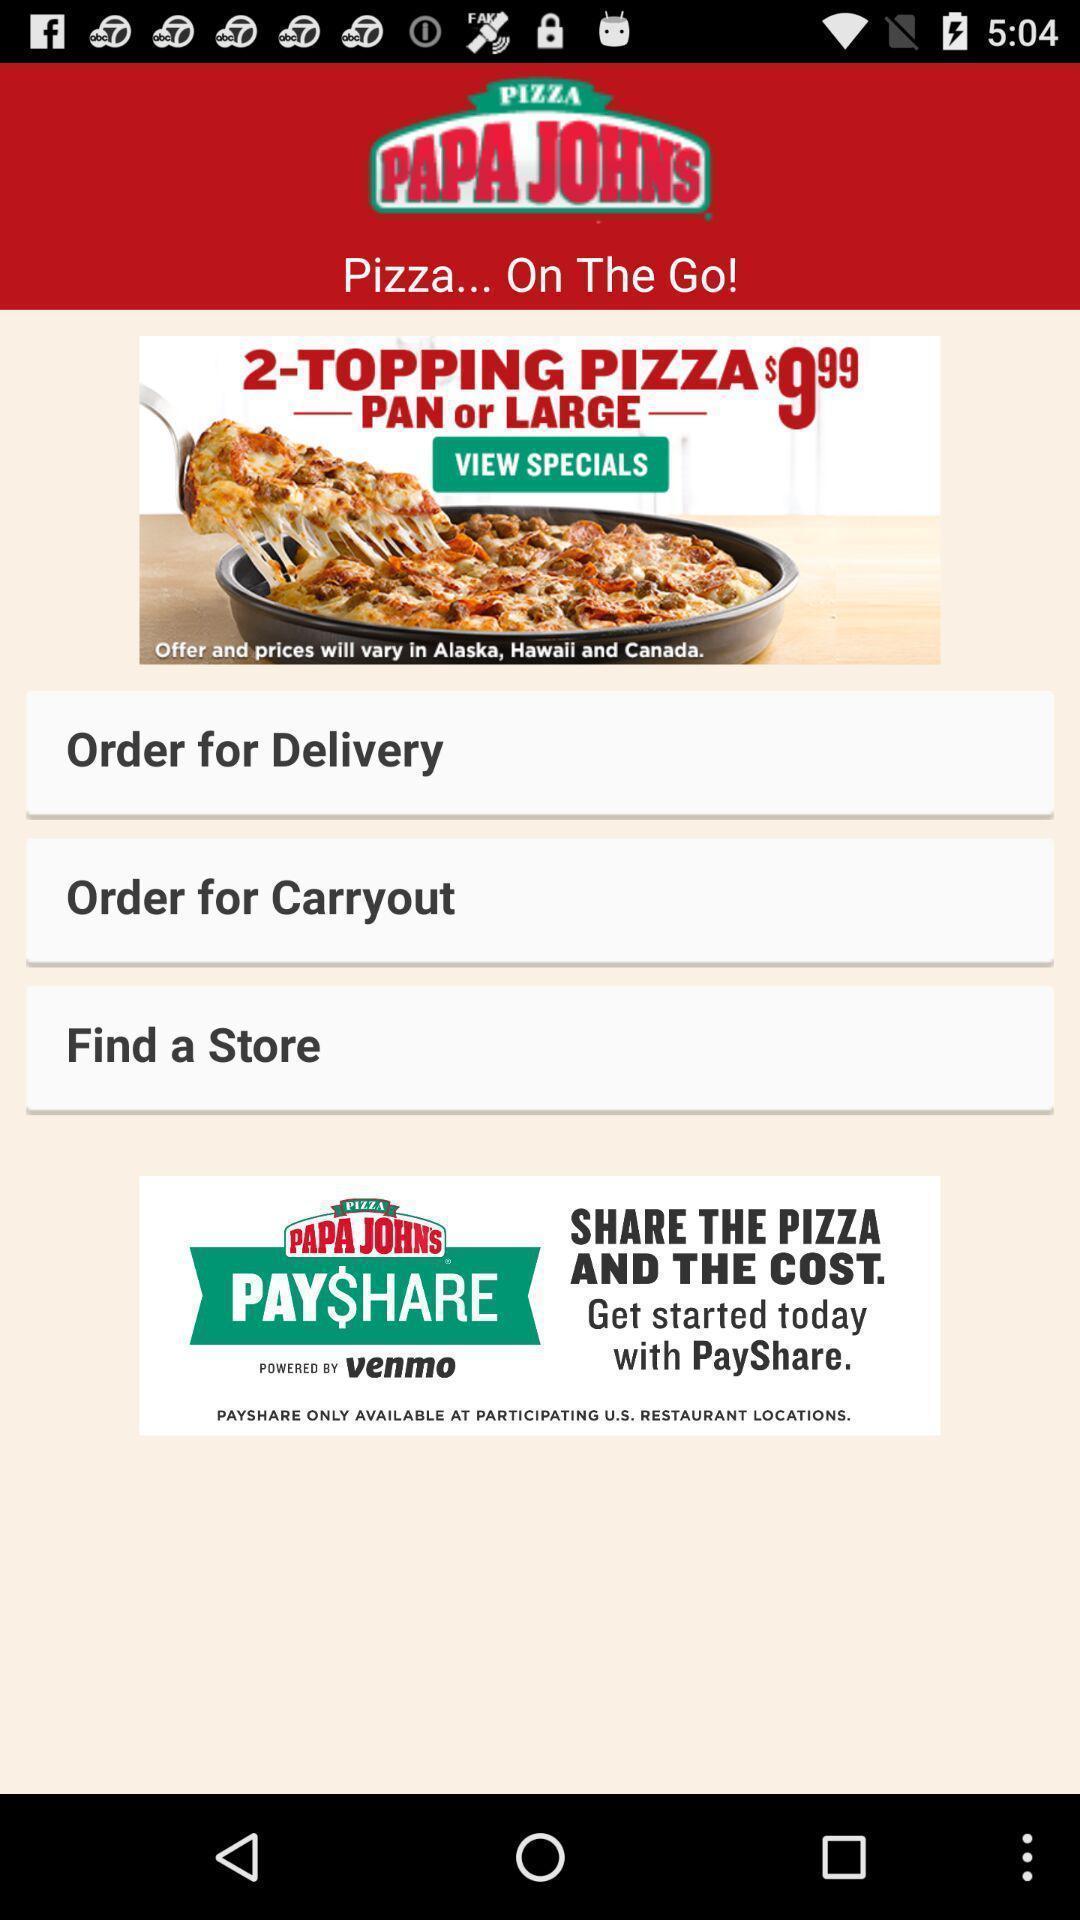Summarize the information in this screenshot. Welcome page of a food ordering app. 